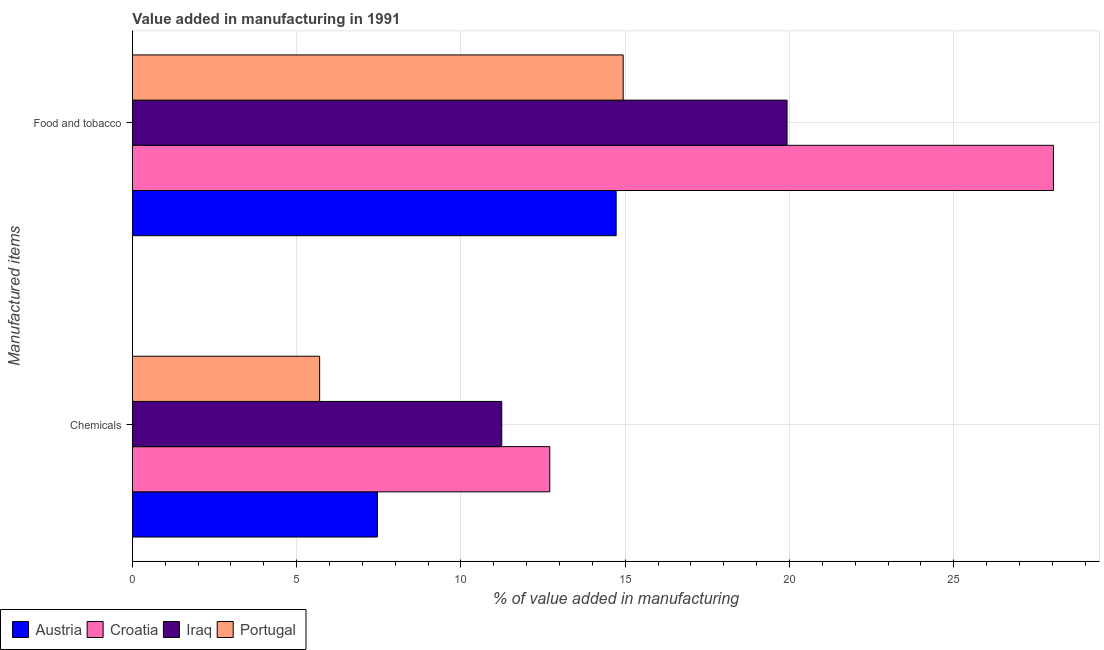How many different coloured bars are there?
Your answer should be compact. 4. How many groups of bars are there?
Provide a short and direct response. 2. Are the number of bars on each tick of the Y-axis equal?
Give a very brief answer. Yes. What is the label of the 2nd group of bars from the top?
Ensure brevity in your answer.  Chemicals. What is the value added by manufacturing food and tobacco in Iraq?
Your response must be concise. 19.93. Across all countries, what is the maximum value added by  manufacturing chemicals?
Keep it short and to the point. 12.7. Across all countries, what is the minimum value added by manufacturing food and tobacco?
Give a very brief answer. 14.72. In which country was the value added by manufacturing food and tobacco maximum?
Keep it short and to the point. Croatia. What is the total value added by  manufacturing chemicals in the graph?
Provide a succinct answer. 37.1. What is the difference between the value added by manufacturing food and tobacco in Iraq and that in Croatia?
Give a very brief answer. -8.11. What is the difference between the value added by  manufacturing chemicals in Portugal and the value added by manufacturing food and tobacco in Iraq?
Keep it short and to the point. -14.23. What is the average value added by  manufacturing chemicals per country?
Keep it short and to the point. 9.28. What is the difference between the value added by  manufacturing chemicals and value added by manufacturing food and tobacco in Portugal?
Offer a very short reply. -9.24. In how many countries, is the value added by  manufacturing chemicals greater than 27 %?
Offer a terse response. 0. What is the ratio of the value added by manufacturing food and tobacco in Iraq to that in Portugal?
Give a very brief answer. 1.33. In how many countries, is the value added by  manufacturing chemicals greater than the average value added by  manufacturing chemicals taken over all countries?
Your answer should be very brief. 2. What does the 1st bar from the top in Food and tobacco represents?
Your answer should be compact. Portugal. What does the 3rd bar from the bottom in Food and tobacco represents?
Your answer should be compact. Iraq. How many bars are there?
Offer a very short reply. 8. Are all the bars in the graph horizontal?
Offer a very short reply. Yes. Where does the legend appear in the graph?
Ensure brevity in your answer.  Bottom left. How many legend labels are there?
Your answer should be compact. 4. What is the title of the graph?
Provide a short and direct response. Value added in manufacturing in 1991. What is the label or title of the X-axis?
Your answer should be very brief. % of value added in manufacturing. What is the label or title of the Y-axis?
Provide a short and direct response. Manufactured items. What is the % of value added in manufacturing of Austria in Chemicals?
Make the answer very short. 7.46. What is the % of value added in manufacturing in Croatia in Chemicals?
Offer a very short reply. 12.7. What is the % of value added in manufacturing of Iraq in Chemicals?
Provide a succinct answer. 11.24. What is the % of value added in manufacturing of Portugal in Chemicals?
Make the answer very short. 5.7. What is the % of value added in manufacturing in Austria in Food and tobacco?
Offer a very short reply. 14.72. What is the % of value added in manufacturing in Croatia in Food and tobacco?
Your answer should be compact. 28.04. What is the % of value added in manufacturing of Iraq in Food and tobacco?
Your response must be concise. 19.93. What is the % of value added in manufacturing of Portugal in Food and tobacco?
Your response must be concise. 14.94. Across all Manufactured items, what is the maximum % of value added in manufacturing in Austria?
Your answer should be compact. 14.72. Across all Manufactured items, what is the maximum % of value added in manufacturing of Croatia?
Make the answer very short. 28.04. Across all Manufactured items, what is the maximum % of value added in manufacturing of Iraq?
Make the answer very short. 19.93. Across all Manufactured items, what is the maximum % of value added in manufacturing in Portugal?
Offer a terse response. 14.94. Across all Manufactured items, what is the minimum % of value added in manufacturing in Austria?
Your response must be concise. 7.46. Across all Manufactured items, what is the minimum % of value added in manufacturing of Croatia?
Provide a succinct answer. 12.7. Across all Manufactured items, what is the minimum % of value added in manufacturing in Iraq?
Your answer should be very brief. 11.24. Across all Manufactured items, what is the minimum % of value added in manufacturing in Portugal?
Provide a succinct answer. 5.7. What is the total % of value added in manufacturing of Austria in the graph?
Provide a short and direct response. 22.18. What is the total % of value added in manufacturing of Croatia in the graph?
Provide a short and direct response. 40.74. What is the total % of value added in manufacturing of Iraq in the graph?
Make the answer very short. 31.17. What is the total % of value added in manufacturing in Portugal in the graph?
Ensure brevity in your answer.  20.64. What is the difference between the % of value added in manufacturing in Austria in Chemicals and that in Food and tobacco?
Provide a succinct answer. -7.27. What is the difference between the % of value added in manufacturing in Croatia in Chemicals and that in Food and tobacco?
Your response must be concise. -15.33. What is the difference between the % of value added in manufacturing of Iraq in Chemicals and that in Food and tobacco?
Make the answer very short. -8.69. What is the difference between the % of value added in manufacturing of Portugal in Chemicals and that in Food and tobacco?
Make the answer very short. -9.24. What is the difference between the % of value added in manufacturing of Austria in Chemicals and the % of value added in manufacturing of Croatia in Food and tobacco?
Your response must be concise. -20.58. What is the difference between the % of value added in manufacturing in Austria in Chemicals and the % of value added in manufacturing in Iraq in Food and tobacco?
Your answer should be very brief. -12.47. What is the difference between the % of value added in manufacturing in Austria in Chemicals and the % of value added in manufacturing in Portugal in Food and tobacco?
Your response must be concise. -7.48. What is the difference between the % of value added in manufacturing of Croatia in Chemicals and the % of value added in manufacturing of Iraq in Food and tobacco?
Make the answer very short. -7.22. What is the difference between the % of value added in manufacturing of Croatia in Chemicals and the % of value added in manufacturing of Portugal in Food and tobacco?
Your answer should be compact. -2.23. What is the difference between the % of value added in manufacturing of Iraq in Chemicals and the % of value added in manufacturing of Portugal in Food and tobacco?
Your answer should be very brief. -3.7. What is the average % of value added in manufacturing in Austria per Manufactured items?
Your answer should be very brief. 11.09. What is the average % of value added in manufacturing in Croatia per Manufactured items?
Ensure brevity in your answer.  20.37. What is the average % of value added in manufacturing in Iraq per Manufactured items?
Give a very brief answer. 15.59. What is the average % of value added in manufacturing in Portugal per Manufactured items?
Keep it short and to the point. 10.32. What is the difference between the % of value added in manufacturing of Austria and % of value added in manufacturing of Croatia in Chemicals?
Your answer should be very brief. -5.25. What is the difference between the % of value added in manufacturing in Austria and % of value added in manufacturing in Iraq in Chemicals?
Your answer should be compact. -3.78. What is the difference between the % of value added in manufacturing of Austria and % of value added in manufacturing of Portugal in Chemicals?
Offer a terse response. 1.76. What is the difference between the % of value added in manufacturing of Croatia and % of value added in manufacturing of Iraq in Chemicals?
Your answer should be compact. 1.46. What is the difference between the % of value added in manufacturing in Croatia and % of value added in manufacturing in Portugal in Chemicals?
Give a very brief answer. 7.01. What is the difference between the % of value added in manufacturing of Iraq and % of value added in manufacturing of Portugal in Chemicals?
Your answer should be very brief. 5.54. What is the difference between the % of value added in manufacturing in Austria and % of value added in manufacturing in Croatia in Food and tobacco?
Your answer should be very brief. -13.31. What is the difference between the % of value added in manufacturing in Austria and % of value added in manufacturing in Iraq in Food and tobacco?
Provide a succinct answer. -5.2. What is the difference between the % of value added in manufacturing of Austria and % of value added in manufacturing of Portugal in Food and tobacco?
Offer a terse response. -0.21. What is the difference between the % of value added in manufacturing in Croatia and % of value added in manufacturing in Iraq in Food and tobacco?
Offer a very short reply. 8.11. What is the difference between the % of value added in manufacturing of Croatia and % of value added in manufacturing of Portugal in Food and tobacco?
Give a very brief answer. 13.1. What is the difference between the % of value added in manufacturing of Iraq and % of value added in manufacturing of Portugal in Food and tobacco?
Keep it short and to the point. 4.99. What is the ratio of the % of value added in manufacturing in Austria in Chemicals to that in Food and tobacco?
Provide a short and direct response. 0.51. What is the ratio of the % of value added in manufacturing in Croatia in Chemicals to that in Food and tobacco?
Offer a terse response. 0.45. What is the ratio of the % of value added in manufacturing of Iraq in Chemicals to that in Food and tobacco?
Provide a succinct answer. 0.56. What is the ratio of the % of value added in manufacturing of Portugal in Chemicals to that in Food and tobacco?
Ensure brevity in your answer.  0.38. What is the difference between the highest and the second highest % of value added in manufacturing of Austria?
Your answer should be very brief. 7.27. What is the difference between the highest and the second highest % of value added in manufacturing in Croatia?
Your response must be concise. 15.33. What is the difference between the highest and the second highest % of value added in manufacturing of Iraq?
Your response must be concise. 8.69. What is the difference between the highest and the second highest % of value added in manufacturing in Portugal?
Offer a terse response. 9.24. What is the difference between the highest and the lowest % of value added in manufacturing in Austria?
Provide a short and direct response. 7.27. What is the difference between the highest and the lowest % of value added in manufacturing in Croatia?
Provide a short and direct response. 15.33. What is the difference between the highest and the lowest % of value added in manufacturing of Iraq?
Provide a succinct answer. 8.69. What is the difference between the highest and the lowest % of value added in manufacturing in Portugal?
Your response must be concise. 9.24. 